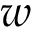Convert formula to latex. <formula><loc_0><loc_0><loc_500><loc_500>w</formula> 